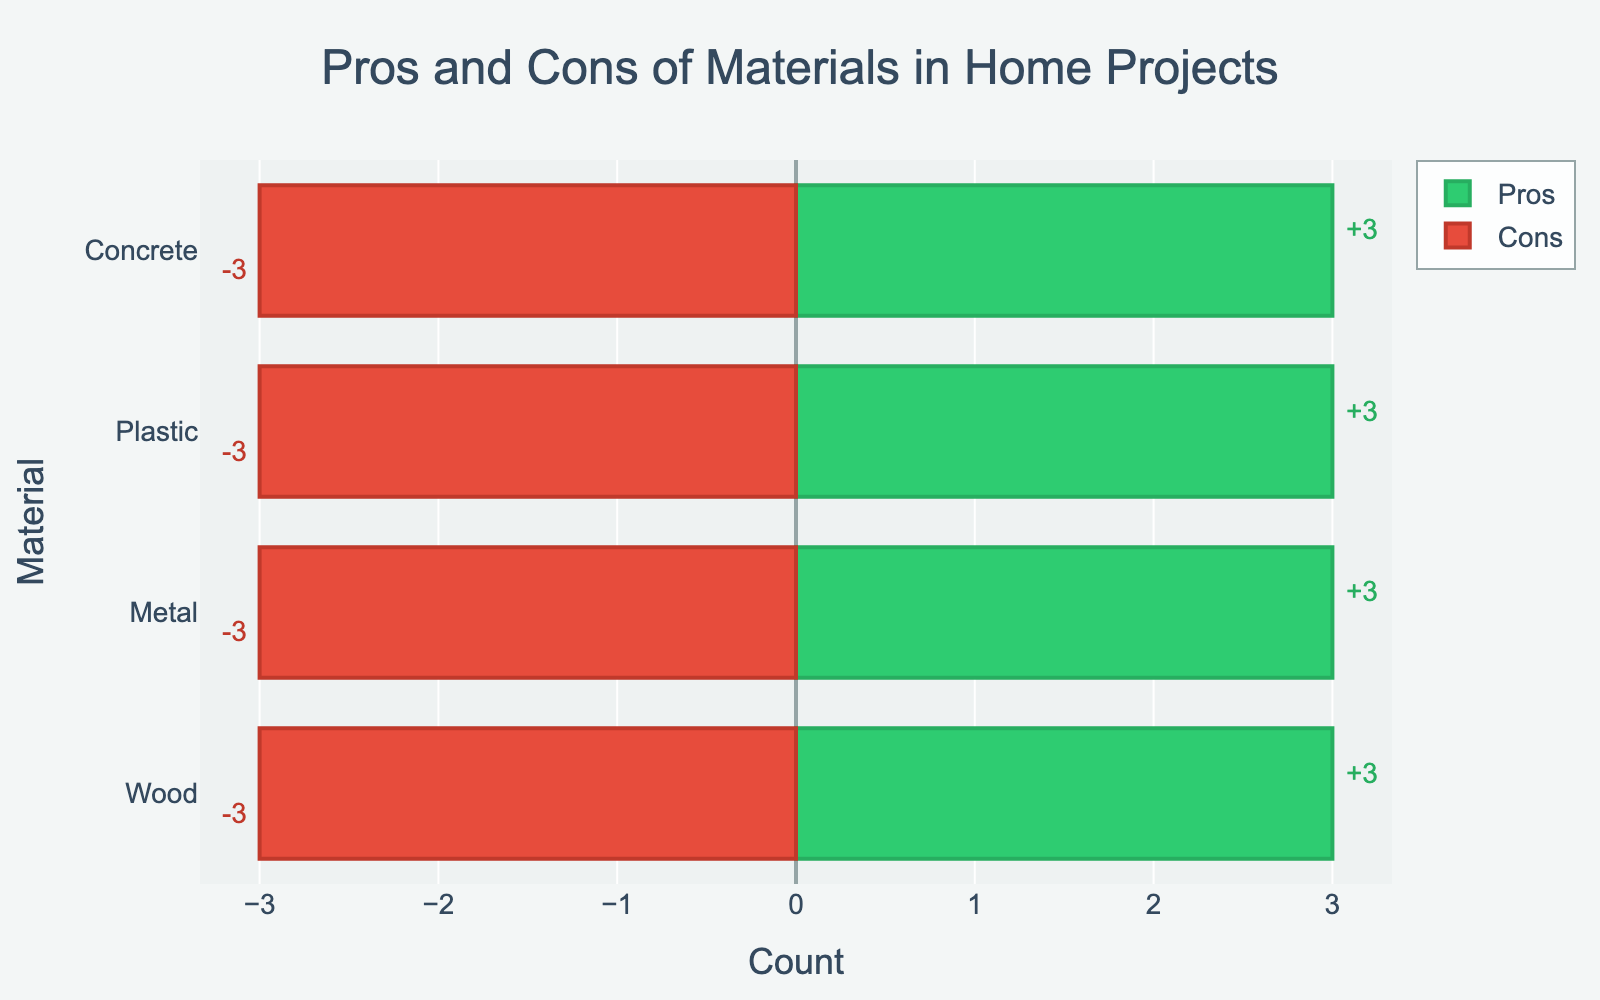What material has the most cons for household projects? By looking at the lengths of the red bars (Cons) in the chart, the material with the longest red bar represents the most cons.
Answer: Wood Which material has the fewest pros? By looking at the lengths of the green bars (Pros) in the chart, the material with the shortest green bar represents the fewest pros.
Answer: Plastic How many pros and cons does concrete have in total? Adding up the lengths of the green (Pros) and red (Cons) bars for concrete. Pros: 3, Cons: 3. So, total is 3 + 3 = 6.
Answer: 6 For which material is the difference between pros and cons the greatest? To find this, we subtract the length of the red bar (Cons) from the length of the green bar (Pros) for each material. The material with the largest difference is the answer.
Answer: Wood Which material has an equal number of pros and cons? By examining the lengths of the green and red bars (Pros and Cons), the material with green and red bars of the same length is the answer.
Answer: Concrete Which material has more pros, wood or metal? By comparing the lengths of the green bars (Pros) for wood and metal, the material with the longer bar has more pros.
Answer: Wood Which material has the same number of cons as plastic has pros? By comparing the lengths of the red bars (Cons) of all other materials to the green bar (Pros) of plastic, we look for which are equal.
Answer: Metal What is the average number of cons across all materials? Sum the lengths of the red bars (Cons) of all materials and divide by the number of materials (4). For wood = 3, metal = 3, plastic = 3, and concrete = 3, the sum is 3 + 3 + 3 + 3 = 12. Average is 12/4 = 3.
Answer: 3 Which material has the second most pros? List out the lengths of green bars (Pros) for all materials and identify which one is the second highest.
Answer: Metal 